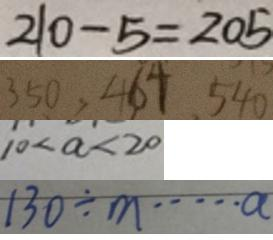Convert formula to latex. <formula><loc_0><loc_0><loc_500><loc_500>2 1 0 - 5 = 2 0 5 
 3 5 0 , 4 6 4 , 5 4 0 
 1 0 < a < 2 0 
 1 3 0 \div m \cdots a</formula> 